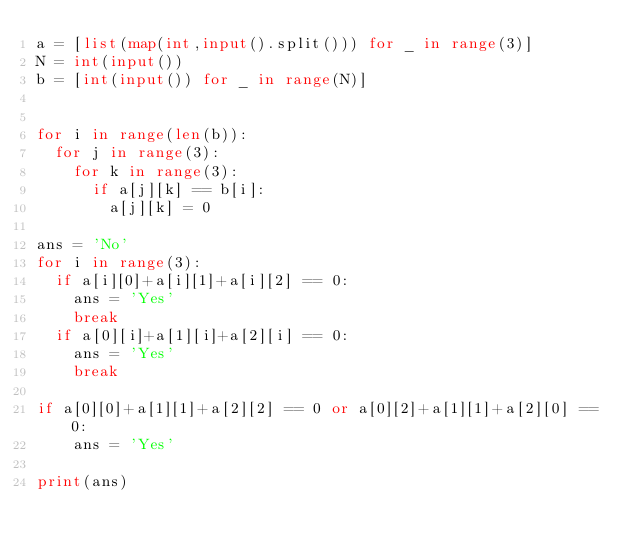Convert code to text. <code><loc_0><loc_0><loc_500><loc_500><_Python_>a = [list(map(int,input().split())) for _ in range(3)]
N = int(input())
b = [int(input()) for _ in range(N)]


for i in range(len(b)):
  for j in range(3):
    for k in range(3):
      if a[j][k] == b[i]:
        a[j][k] = 0
      
ans = 'No'
for i in range(3):
  if a[i][0]+a[i][1]+a[i][2] == 0:
    ans = 'Yes'
    break
  if a[0][i]+a[1][i]+a[2][i] == 0:
    ans = 'Yes'
    break

if a[0][0]+a[1][1]+a[2][2] == 0 or a[0][2]+a[1][1]+a[2][0] == 0:
    ans = 'Yes'

print(ans)</code> 